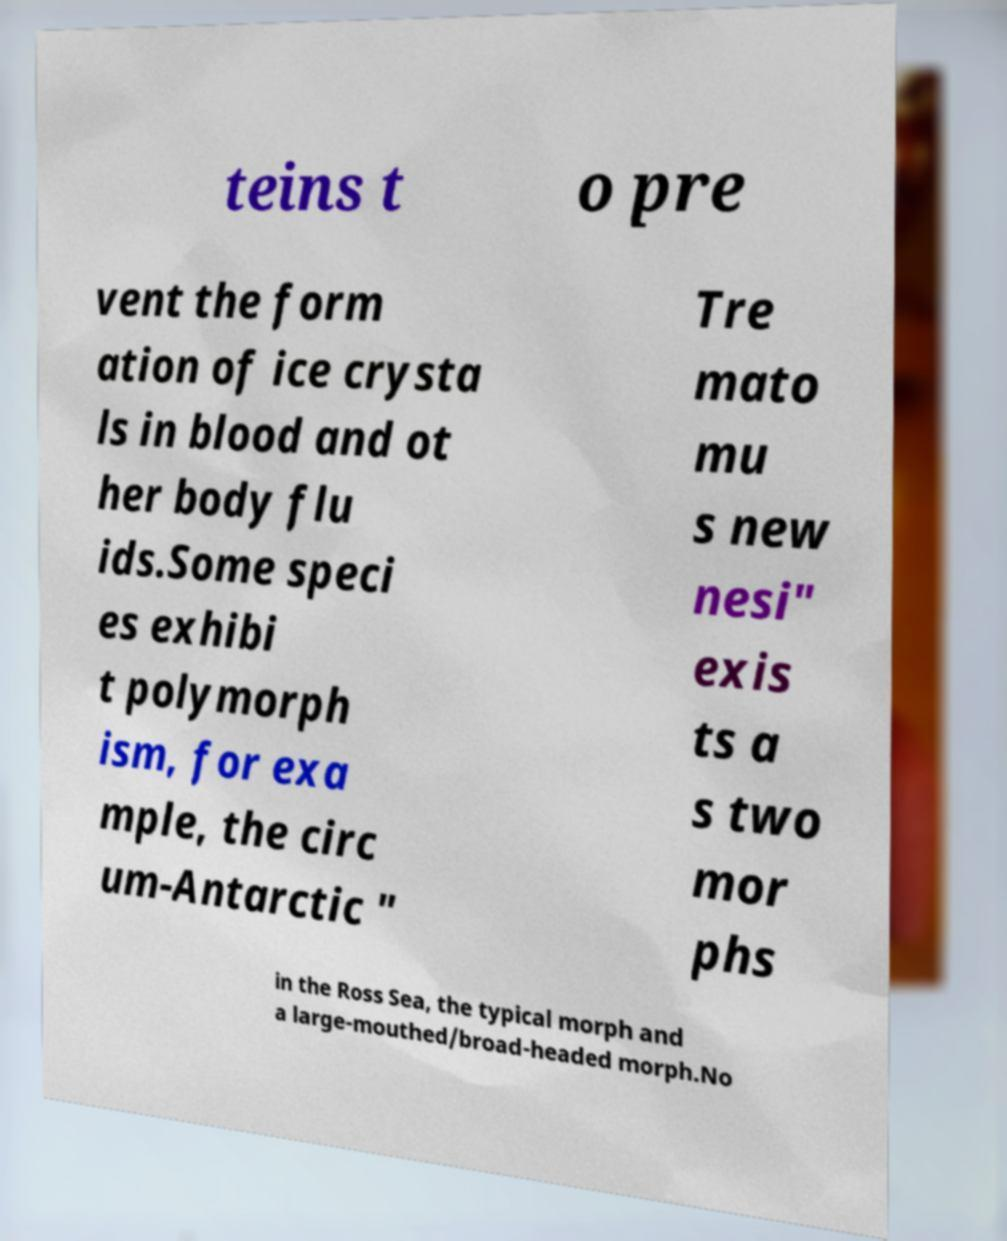Please identify and transcribe the text found in this image. teins t o pre vent the form ation of ice crysta ls in blood and ot her body flu ids.Some speci es exhibi t polymorph ism, for exa mple, the circ um-Antarctic " Tre mato mu s new nesi" exis ts a s two mor phs in the Ross Sea, the typical morph and a large-mouthed/broad-headed morph.No 